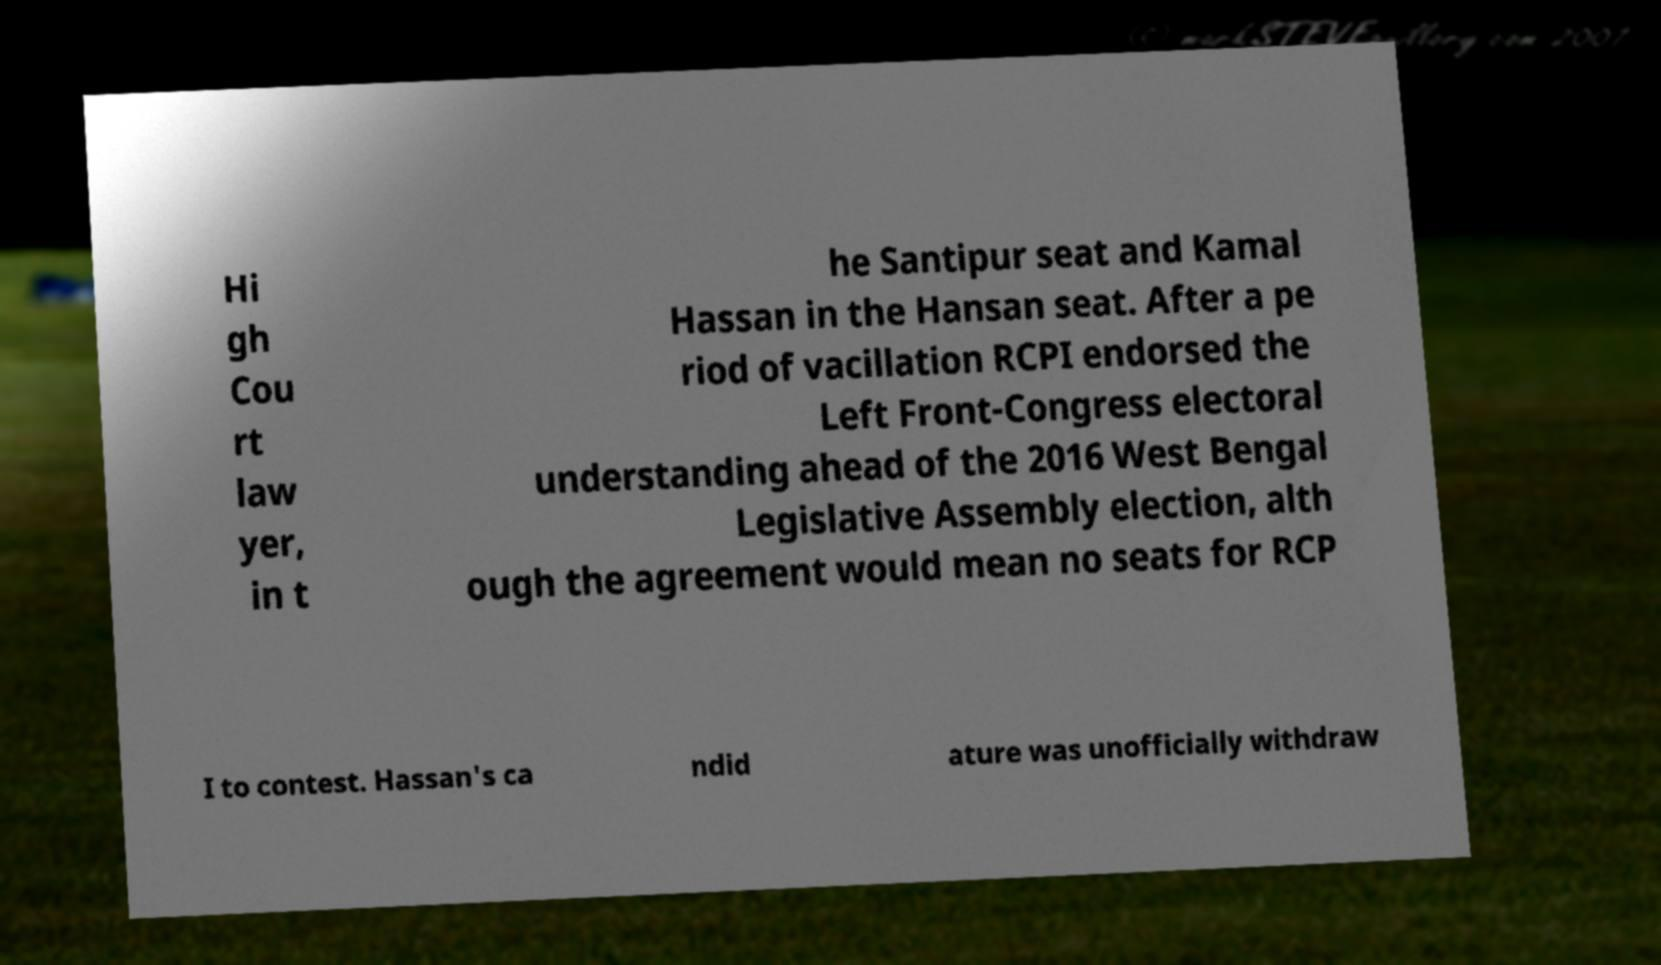I need the written content from this picture converted into text. Can you do that? Hi gh Cou rt law yer, in t he Santipur seat and Kamal Hassan in the Hansan seat. After a pe riod of vacillation RCPI endorsed the Left Front-Congress electoral understanding ahead of the 2016 West Bengal Legislative Assembly election, alth ough the agreement would mean no seats for RCP I to contest. Hassan's ca ndid ature was unofficially withdraw 